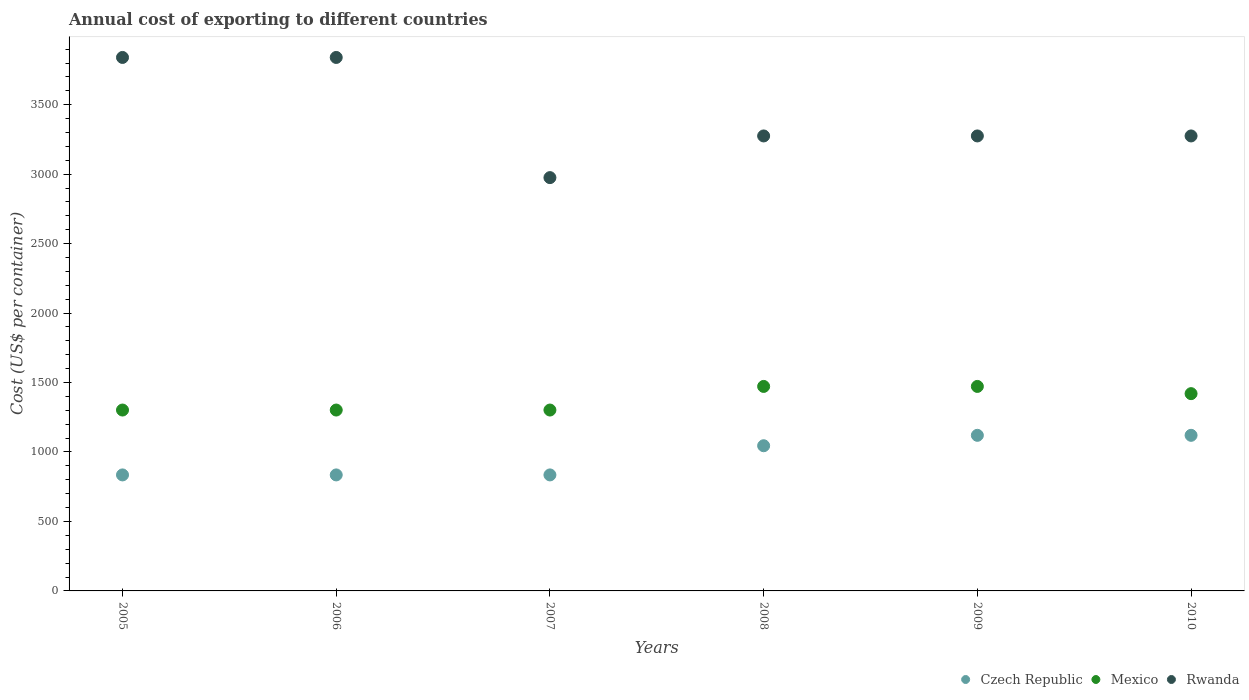Is the number of dotlines equal to the number of legend labels?
Your answer should be very brief. Yes. What is the total annual cost of exporting in Czech Republic in 2007?
Your answer should be very brief. 835. Across all years, what is the maximum total annual cost of exporting in Rwanda?
Provide a short and direct response. 3840. Across all years, what is the minimum total annual cost of exporting in Czech Republic?
Provide a succinct answer. 835. What is the total total annual cost of exporting in Mexico in the graph?
Your response must be concise. 8270. What is the difference between the total annual cost of exporting in Rwanda in 2006 and that in 2007?
Offer a terse response. 865. What is the difference between the total annual cost of exporting in Rwanda in 2009 and the total annual cost of exporting in Czech Republic in 2007?
Keep it short and to the point. 2440. What is the average total annual cost of exporting in Czech Republic per year?
Your response must be concise. 965. In the year 2007, what is the difference between the total annual cost of exporting in Mexico and total annual cost of exporting in Rwanda?
Give a very brief answer. -1673. What is the ratio of the total annual cost of exporting in Mexico in 2006 to that in 2008?
Your answer should be very brief. 0.88. What is the difference between the highest and the lowest total annual cost of exporting in Mexico?
Give a very brief answer. 170. Is the sum of the total annual cost of exporting in Czech Republic in 2008 and 2009 greater than the maximum total annual cost of exporting in Rwanda across all years?
Offer a terse response. No. Is it the case that in every year, the sum of the total annual cost of exporting in Rwanda and total annual cost of exporting in Mexico  is greater than the total annual cost of exporting in Czech Republic?
Keep it short and to the point. Yes. Is the total annual cost of exporting in Rwanda strictly greater than the total annual cost of exporting in Mexico over the years?
Your response must be concise. Yes. How many dotlines are there?
Make the answer very short. 3. How many years are there in the graph?
Offer a terse response. 6. What is the difference between two consecutive major ticks on the Y-axis?
Your answer should be very brief. 500. Does the graph contain any zero values?
Offer a very short reply. No. Does the graph contain grids?
Provide a succinct answer. No. Where does the legend appear in the graph?
Your response must be concise. Bottom right. How many legend labels are there?
Your response must be concise. 3. How are the legend labels stacked?
Offer a very short reply. Horizontal. What is the title of the graph?
Your answer should be very brief. Annual cost of exporting to different countries. Does "Arab World" appear as one of the legend labels in the graph?
Your answer should be compact. No. What is the label or title of the Y-axis?
Your response must be concise. Cost (US$ per container). What is the Cost (US$ per container) of Czech Republic in 2005?
Your answer should be very brief. 835. What is the Cost (US$ per container) in Mexico in 2005?
Offer a terse response. 1302. What is the Cost (US$ per container) of Rwanda in 2005?
Offer a very short reply. 3840. What is the Cost (US$ per container) of Czech Republic in 2006?
Your answer should be very brief. 835. What is the Cost (US$ per container) in Mexico in 2006?
Your answer should be compact. 1302. What is the Cost (US$ per container) in Rwanda in 2006?
Ensure brevity in your answer.  3840. What is the Cost (US$ per container) of Czech Republic in 2007?
Your answer should be compact. 835. What is the Cost (US$ per container) in Mexico in 2007?
Your answer should be very brief. 1302. What is the Cost (US$ per container) of Rwanda in 2007?
Your response must be concise. 2975. What is the Cost (US$ per container) in Czech Republic in 2008?
Provide a succinct answer. 1045. What is the Cost (US$ per container) in Mexico in 2008?
Your answer should be compact. 1472. What is the Cost (US$ per container) of Rwanda in 2008?
Your response must be concise. 3275. What is the Cost (US$ per container) in Czech Republic in 2009?
Your answer should be compact. 1120. What is the Cost (US$ per container) of Mexico in 2009?
Your response must be concise. 1472. What is the Cost (US$ per container) in Rwanda in 2009?
Your response must be concise. 3275. What is the Cost (US$ per container) in Czech Republic in 2010?
Ensure brevity in your answer.  1120. What is the Cost (US$ per container) in Mexico in 2010?
Ensure brevity in your answer.  1420. What is the Cost (US$ per container) in Rwanda in 2010?
Provide a succinct answer. 3275. Across all years, what is the maximum Cost (US$ per container) in Czech Republic?
Keep it short and to the point. 1120. Across all years, what is the maximum Cost (US$ per container) in Mexico?
Provide a succinct answer. 1472. Across all years, what is the maximum Cost (US$ per container) of Rwanda?
Provide a succinct answer. 3840. Across all years, what is the minimum Cost (US$ per container) of Czech Republic?
Offer a very short reply. 835. Across all years, what is the minimum Cost (US$ per container) in Mexico?
Ensure brevity in your answer.  1302. Across all years, what is the minimum Cost (US$ per container) in Rwanda?
Offer a very short reply. 2975. What is the total Cost (US$ per container) of Czech Republic in the graph?
Your answer should be very brief. 5790. What is the total Cost (US$ per container) in Mexico in the graph?
Keep it short and to the point. 8270. What is the total Cost (US$ per container) in Rwanda in the graph?
Offer a very short reply. 2.05e+04. What is the difference between the Cost (US$ per container) of Czech Republic in 2005 and that in 2006?
Offer a terse response. 0. What is the difference between the Cost (US$ per container) of Rwanda in 2005 and that in 2006?
Your answer should be very brief. 0. What is the difference between the Cost (US$ per container) in Mexico in 2005 and that in 2007?
Your answer should be very brief. 0. What is the difference between the Cost (US$ per container) in Rwanda in 2005 and that in 2007?
Offer a very short reply. 865. What is the difference between the Cost (US$ per container) of Czech Republic in 2005 and that in 2008?
Offer a very short reply. -210. What is the difference between the Cost (US$ per container) in Mexico in 2005 and that in 2008?
Keep it short and to the point. -170. What is the difference between the Cost (US$ per container) of Rwanda in 2005 and that in 2008?
Keep it short and to the point. 565. What is the difference between the Cost (US$ per container) of Czech Republic in 2005 and that in 2009?
Your answer should be very brief. -285. What is the difference between the Cost (US$ per container) of Mexico in 2005 and that in 2009?
Offer a terse response. -170. What is the difference between the Cost (US$ per container) in Rwanda in 2005 and that in 2009?
Offer a very short reply. 565. What is the difference between the Cost (US$ per container) in Czech Republic in 2005 and that in 2010?
Your answer should be very brief. -285. What is the difference between the Cost (US$ per container) in Mexico in 2005 and that in 2010?
Your answer should be very brief. -118. What is the difference between the Cost (US$ per container) of Rwanda in 2005 and that in 2010?
Your response must be concise. 565. What is the difference between the Cost (US$ per container) in Mexico in 2006 and that in 2007?
Provide a short and direct response. 0. What is the difference between the Cost (US$ per container) of Rwanda in 2006 and that in 2007?
Provide a short and direct response. 865. What is the difference between the Cost (US$ per container) in Czech Republic in 2006 and that in 2008?
Ensure brevity in your answer.  -210. What is the difference between the Cost (US$ per container) of Mexico in 2006 and that in 2008?
Provide a succinct answer. -170. What is the difference between the Cost (US$ per container) in Rwanda in 2006 and that in 2008?
Offer a terse response. 565. What is the difference between the Cost (US$ per container) in Czech Republic in 2006 and that in 2009?
Provide a succinct answer. -285. What is the difference between the Cost (US$ per container) in Mexico in 2006 and that in 2009?
Your answer should be compact. -170. What is the difference between the Cost (US$ per container) of Rwanda in 2006 and that in 2009?
Your answer should be very brief. 565. What is the difference between the Cost (US$ per container) in Czech Republic in 2006 and that in 2010?
Ensure brevity in your answer.  -285. What is the difference between the Cost (US$ per container) in Mexico in 2006 and that in 2010?
Make the answer very short. -118. What is the difference between the Cost (US$ per container) of Rwanda in 2006 and that in 2010?
Ensure brevity in your answer.  565. What is the difference between the Cost (US$ per container) of Czech Republic in 2007 and that in 2008?
Offer a terse response. -210. What is the difference between the Cost (US$ per container) of Mexico in 2007 and that in 2008?
Ensure brevity in your answer.  -170. What is the difference between the Cost (US$ per container) of Rwanda in 2007 and that in 2008?
Provide a short and direct response. -300. What is the difference between the Cost (US$ per container) in Czech Republic in 2007 and that in 2009?
Your answer should be compact. -285. What is the difference between the Cost (US$ per container) in Mexico in 2007 and that in 2009?
Keep it short and to the point. -170. What is the difference between the Cost (US$ per container) of Rwanda in 2007 and that in 2009?
Your response must be concise. -300. What is the difference between the Cost (US$ per container) in Czech Republic in 2007 and that in 2010?
Provide a succinct answer. -285. What is the difference between the Cost (US$ per container) in Mexico in 2007 and that in 2010?
Keep it short and to the point. -118. What is the difference between the Cost (US$ per container) in Rwanda in 2007 and that in 2010?
Your answer should be compact. -300. What is the difference between the Cost (US$ per container) in Czech Republic in 2008 and that in 2009?
Make the answer very short. -75. What is the difference between the Cost (US$ per container) in Czech Republic in 2008 and that in 2010?
Provide a short and direct response. -75. What is the difference between the Cost (US$ per container) of Mexico in 2008 and that in 2010?
Your answer should be very brief. 52. What is the difference between the Cost (US$ per container) in Czech Republic in 2005 and the Cost (US$ per container) in Mexico in 2006?
Your answer should be compact. -467. What is the difference between the Cost (US$ per container) in Czech Republic in 2005 and the Cost (US$ per container) in Rwanda in 2006?
Offer a terse response. -3005. What is the difference between the Cost (US$ per container) of Mexico in 2005 and the Cost (US$ per container) of Rwanda in 2006?
Offer a very short reply. -2538. What is the difference between the Cost (US$ per container) of Czech Republic in 2005 and the Cost (US$ per container) of Mexico in 2007?
Your response must be concise. -467. What is the difference between the Cost (US$ per container) in Czech Republic in 2005 and the Cost (US$ per container) in Rwanda in 2007?
Keep it short and to the point. -2140. What is the difference between the Cost (US$ per container) of Mexico in 2005 and the Cost (US$ per container) of Rwanda in 2007?
Offer a terse response. -1673. What is the difference between the Cost (US$ per container) in Czech Republic in 2005 and the Cost (US$ per container) in Mexico in 2008?
Make the answer very short. -637. What is the difference between the Cost (US$ per container) of Czech Republic in 2005 and the Cost (US$ per container) of Rwanda in 2008?
Keep it short and to the point. -2440. What is the difference between the Cost (US$ per container) of Mexico in 2005 and the Cost (US$ per container) of Rwanda in 2008?
Give a very brief answer. -1973. What is the difference between the Cost (US$ per container) of Czech Republic in 2005 and the Cost (US$ per container) of Mexico in 2009?
Your response must be concise. -637. What is the difference between the Cost (US$ per container) in Czech Republic in 2005 and the Cost (US$ per container) in Rwanda in 2009?
Your answer should be compact. -2440. What is the difference between the Cost (US$ per container) of Mexico in 2005 and the Cost (US$ per container) of Rwanda in 2009?
Make the answer very short. -1973. What is the difference between the Cost (US$ per container) of Czech Republic in 2005 and the Cost (US$ per container) of Mexico in 2010?
Provide a succinct answer. -585. What is the difference between the Cost (US$ per container) of Czech Republic in 2005 and the Cost (US$ per container) of Rwanda in 2010?
Your response must be concise. -2440. What is the difference between the Cost (US$ per container) of Mexico in 2005 and the Cost (US$ per container) of Rwanda in 2010?
Give a very brief answer. -1973. What is the difference between the Cost (US$ per container) of Czech Republic in 2006 and the Cost (US$ per container) of Mexico in 2007?
Your answer should be compact. -467. What is the difference between the Cost (US$ per container) in Czech Republic in 2006 and the Cost (US$ per container) in Rwanda in 2007?
Provide a succinct answer. -2140. What is the difference between the Cost (US$ per container) of Mexico in 2006 and the Cost (US$ per container) of Rwanda in 2007?
Keep it short and to the point. -1673. What is the difference between the Cost (US$ per container) of Czech Republic in 2006 and the Cost (US$ per container) of Mexico in 2008?
Make the answer very short. -637. What is the difference between the Cost (US$ per container) of Czech Republic in 2006 and the Cost (US$ per container) of Rwanda in 2008?
Give a very brief answer. -2440. What is the difference between the Cost (US$ per container) in Mexico in 2006 and the Cost (US$ per container) in Rwanda in 2008?
Make the answer very short. -1973. What is the difference between the Cost (US$ per container) of Czech Republic in 2006 and the Cost (US$ per container) of Mexico in 2009?
Keep it short and to the point. -637. What is the difference between the Cost (US$ per container) in Czech Republic in 2006 and the Cost (US$ per container) in Rwanda in 2009?
Your answer should be compact. -2440. What is the difference between the Cost (US$ per container) in Mexico in 2006 and the Cost (US$ per container) in Rwanda in 2009?
Provide a short and direct response. -1973. What is the difference between the Cost (US$ per container) in Czech Republic in 2006 and the Cost (US$ per container) in Mexico in 2010?
Your response must be concise. -585. What is the difference between the Cost (US$ per container) in Czech Republic in 2006 and the Cost (US$ per container) in Rwanda in 2010?
Offer a very short reply. -2440. What is the difference between the Cost (US$ per container) in Mexico in 2006 and the Cost (US$ per container) in Rwanda in 2010?
Your answer should be compact. -1973. What is the difference between the Cost (US$ per container) in Czech Republic in 2007 and the Cost (US$ per container) in Mexico in 2008?
Give a very brief answer. -637. What is the difference between the Cost (US$ per container) of Czech Republic in 2007 and the Cost (US$ per container) of Rwanda in 2008?
Give a very brief answer. -2440. What is the difference between the Cost (US$ per container) in Mexico in 2007 and the Cost (US$ per container) in Rwanda in 2008?
Give a very brief answer. -1973. What is the difference between the Cost (US$ per container) in Czech Republic in 2007 and the Cost (US$ per container) in Mexico in 2009?
Ensure brevity in your answer.  -637. What is the difference between the Cost (US$ per container) of Czech Republic in 2007 and the Cost (US$ per container) of Rwanda in 2009?
Keep it short and to the point. -2440. What is the difference between the Cost (US$ per container) in Mexico in 2007 and the Cost (US$ per container) in Rwanda in 2009?
Offer a terse response. -1973. What is the difference between the Cost (US$ per container) in Czech Republic in 2007 and the Cost (US$ per container) in Mexico in 2010?
Give a very brief answer. -585. What is the difference between the Cost (US$ per container) of Czech Republic in 2007 and the Cost (US$ per container) of Rwanda in 2010?
Provide a succinct answer. -2440. What is the difference between the Cost (US$ per container) of Mexico in 2007 and the Cost (US$ per container) of Rwanda in 2010?
Keep it short and to the point. -1973. What is the difference between the Cost (US$ per container) in Czech Republic in 2008 and the Cost (US$ per container) in Mexico in 2009?
Provide a succinct answer. -427. What is the difference between the Cost (US$ per container) of Czech Republic in 2008 and the Cost (US$ per container) of Rwanda in 2009?
Your answer should be compact. -2230. What is the difference between the Cost (US$ per container) of Mexico in 2008 and the Cost (US$ per container) of Rwanda in 2009?
Make the answer very short. -1803. What is the difference between the Cost (US$ per container) of Czech Republic in 2008 and the Cost (US$ per container) of Mexico in 2010?
Keep it short and to the point. -375. What is the difference between the Cost (US$ per container) in Czech Republic in 2008 and the Cost (US$ per container) in Rwanda in 2010?
Give a very brief answer. -2230. What is the difference between the Cost (US$ per container) in Mexico in 2008 and the Cost (US$ per container) in Rwanda in 2010?
Ensure brevity in your answer.  -1803. What is the difference between the Cost (US$ per container) of Czech Republic in 2009 and the Cost (US$ per container) of Mexico in 2010?
Keep it short and to the point. -300. What is the difference between the Cost (US$ per container) of Czech Republic in 2009 and the Cost (US$ per container) of Rwanda in 2010?
Give a very brief answer. -2155. What is the difference between the Cost (US$ per container) in Mexico in 2009 and the Cost (US$ per container) in Rwanda in 2010?
Provide a succinct answer. -1803. What is the average Cost (US$ per container) in Czech Republic per year?
Your answer should be compact. 965. What is the average Cost (US$ per container) of Mexico per year?
Give a very brief answer. 1378.33. What is the average Cost (US$ per container) in Rwanda per year?
Provide a succinct answer. 3413.33. In the year 2005, what is the difference between the Cost (US$ per container) of Czech Republic and Cost (US$ per container) of Mexico?
Provide a short and direct response. -467. In the year 2005, what is the difference between the Cost (US$ per container) in Czech Republic and Cost (US$ per container) in Rwanda?
Make the answer very short. -3005. In the year 2005, what is the difference between the Cost (US$ per container) of Mexico and Cost (US$ per container) of Rwanda?
Your answer should be compact. -2538. In the year 2006, what is the difference between the Cost (US$ per container) in Czech Republic and Cost (US$ per container) in Mexico?
Provide a short and direct response. -467. In the year 2006, what is the difference between the Cost (US$ per container) of Czech Republic and Cost (US$ per container) of Rwanda?
Keep it short and to the point. -3005. In the year 2006, what is the difference between the Cost (US$ per container) of Mexico and Cost (US$ per container) of Rwanda?
Ensure brevity in your answer.  -2538. In the year 2007, what is the difference between the Cost (US$ per container) of Czech Republic and Cost (US$ per container) of Mexico?
Your response must be concise. -467. In the year 2007, what is the difference between the Cost (US$ per container) in Czech Republic and Cost (US$ per container) in Rwanda?
Offer a very short reply. -2140. In the year 2007, what is the difference between the Cost (US$ per container) of Mexico and Cost (US$ per container) of Rwanda?
Your response must be concise. -1673. In the year 2008, what is the difference between the Cost (US$ per container) of Czech Republic and Cost (US$ per container) of Mexico?
Offer a terse response. -427. In the year 2008, what is the difference between the Cost (US$ per container) of Czech Republic and Cost (US$ per container) of Rwanda?
Provide a short and direct response. -2230. In the year 2008, what is the difference between the Cost (US$ per container) in Mexico and Cost (US$ per container) in Rwanda?
Provide a short and direct response. -1803. In the year 2009, what is the difference between the Cost (US$ per container) in Czech Republic and Cost (US$ per container) in Mexico?
Offer a very short reply. -352. In the year 2009, what is the difference between the Cost (US$ per container) of Czech Republic and Cost (US$ per container) of Rwanda?
Your answer should be compact. -2155. In the year 2009, what is the difference between the Cost (US$ per container) in Mexico and Cost (US$ per container) in Rwanda?
Your answer should be compact. -1803. In the year 2010, what is the difference between the Cost (US$ per container) of Czech Republic and Cost (US$ per container) of Mexico?
Offer a terse response. -300. In the year 2010, what is the difference between the Cost (US$ per container) in Czech Republic and Cost (US$ per container) in Rwanda?
Your answer should be compact. -2155. In the year 2010, what is the difference between the Cost (US$ per container) of Mexico and Cost (US$ per container) of Rwanda?
Your answer should be compact. -1855. What is the ratio of the Cost (US$ per container) of Czech Republic in 2005 to that in 2006?
Your answer should be very brief. 1. What is the ratio of the Cost (US$ per container) of Rwanda in 2005 to that in 2006?
Provide a succinct answer. 1. What is the ratio of the Cost (US$ per container) in Czech Republic in 2005 to that in 2007?
Provide a short and direct response. 1. What is the ratio of the Cost (US$ per container) of Mexico in 2005 to that in 2007?
Keep it short and to the point. 1. What is the ratio of the Cost (US$ per container) of Rwanda in 2005 to that in 2007?
Your answer should be very brief. 1.29. What is the ratio of the Cost (US$ per container) in Czech Republic in 2005 to that in 2008?
Keep it short and to the point. 0.8. What is the ratio of the Cost (US$ per container) in Mexico in 2005 to that in 2008?
Make the answer very short. 0.88. What is the ratio of the Cost (US$ per container) of Rwanda in 2005 to that in 2008?
Keep it short and to the point. 1.17. What is the ratio of the Cost (US$ per container) of Czech Republic in 2005 to that in 2009?
Ensure brevity in your answer.  0.75. What is the ratio of the Cost (US$ per container) in Mexico in 2005 to that in 2009?
Offer a very short reply. 0.88. What is the ratio of the Cost (US$ per container) of Rwanda in 2005 to that in 2009?
Make the answer very short. 1.17. What is the ratio of the Cost (US$ per container) in Czech Republic in 2005 to that in 2010?
Your answer should be compact. 0.75. What is the ratio of the Cost (US$ per container) of Mexico in 2005 to that in 2010?
Your response must be concise. 0.92. What is the ratio of the Cost (US$ per container) of Rwanda in 2005 to that in 2010?
Ensure brevity in your answer.  1.17. What is the ratio of the Cost (US$ per container) of Czech Republic in 2006 to that in 2007?
Your answer should be very brief. 1. What is the ratio of the Cost (US$ per container) in Mexico in 2006 to that in 2007?
Keep it short and to the point. 1. What is the ratio of the Cost (US$ per container) of Rwanda in 2006 to that in 2007?
Provide a succinct answer. 1.29. What is the ratio of the Cost (US$ per container) of Czech Republic in 2006 to that in 2008?
Ensure brevity in your answer.  0.8. What is the ratio of the Cost (US$ per container) of Mexico in 2006 to that in 2008?
Your answer should be compact. 0.88. What is the ratio of the Cost (US$ per container) of Rwanda in 2006 to that in 2008?
Provide a succinct answer. 1.17. What is the ratio of the Cost (US$ per container) of Czech Republic in 2006 to that in 2009?
Your response must be concise. 0.75. What is the ratio of the Cost (US$ per container) in Mexico in 2006 to that in 2009?
Provide a short and direct response. 0.88. What is the ratio of the Cost (US$ per container) in Rwanda in 2006 to that in 2009?
Your answer should be compact. 1.17. What is the ratio of the Cost (US$ per container) in Czech Republic in 2006 to that in 2010?
Offer a very short reply. 0.75. What is the ratio of the Cost (US$ per container) of Mexico in 2006 to that in 2010?
Offer a terse response. 0.92. What is the ratio of the Cost (US$ per container) in Rwanda in 2006 to that in 2010?
Provide a short and direct response. 1.17. What is the ratio of the Cost (US$ per container) of Czech Republic in 2007 to that in 2008?
Offer a very short reply. 0.8. What is the ratio of the Cost (US$ per container) of Mexico in 2007 to that in 2008?
Your response must be concise. 0.88. What is the ratio of the Cost (US$ per container) of Rwanda in 2007 to that in 2008?
Your response must be concise. 0.91. What is the ratio of the Cost (US$ per container) of Czech Republic in 2007 to that in 2009?
Provide a succinct answer. 0.75. What is the ratio of the Cost (US$ per container) in Mexico in 2007 to that in 2009?
Keep it short and to the point. 0.88. What is the ratio of the Cost (US$ per container) in Rwanda in 2007 to that in 2009?
Make the answer very short. 0.91. What is the ratio of the Cost (US$ per container) of Czech Republic in 2007 to that in 2010?
Your response must be concise. 0.75. What is the ratio of the Cost (US$ per container) in Mexico in 2007 to that in 2010?
Give a very brief answer. 0.92. What is the ratio of the Cost (US$ per container) of Rwanda in 2007 to that in 2010?
Keep it short and to the point. 0.91. What is the ratio of the Cost (US$ per container) in Czech Republic in 2008 to that in 2009?
Offer a very short reply. 0.93. What is the ratio of the Cost (US$ per container) in Czech Republic in 2008 to that in 2010?
Keep it short and to the point. 0.93. What is the ratio of the Cost (US$ per container) of Mexico in 2008 to that in 2010?
Ensure brevity in your answer.  1.04. What is the ratio of the Cost (US$ per container) in Rwanda in 2008 to that in 2010?
Provide a short and direct response. 1. What is the ratio of the Cost (US$ per container) in Czech Republic in 2009 to that in 2010?
Your answer should be very brief. 1. What is the ratio of the Cost (US$ per container) of Mexico in 2009 to that in 2010?
Your answer should be compact. 1.04. What is the difference between the highest and the second highest Cost (US$ per container) of Czech Republic?
Your response must be concise. 0. What is the difference between the highest and the second highest Cost (US$ per container) in Mexico?
Provide a succinct answer. 0. What is the difference between the highest and the second highest Cost (US$ per container) in Rwanda?
Offer a very short reply. 0. What is the difference between the highest and the lowest Cost (US$ per container) of Czech Republic?
Offer a very short reply. 285. What is the difference between the highest and the lowest Cost (US$ per container) in Mexico?
Your answer should be compact. 170. What is the difference between the highest and the lowest Cost (US$ per container) of Rwanda?
Offer a very short reply. 865. 